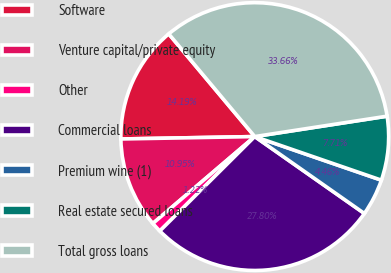Convert chart to OTSL. <chart><loc_0><loc_0><loc_500><loc_500><pie_chart><fcel>Software<fcel>Venture capital/private equity<fcel>Other<fcel>Commercial loans<fcel>Premium wine (1)<fcel>Real estate secured loans<fcel>Total gross loans<nl><fcel>14.19%<fcel>10.95%<fcel>1.22%<fcel>27.8%<fcel>4.46%<fcel>7.71%<fcel>33.66%<nl></chart> 